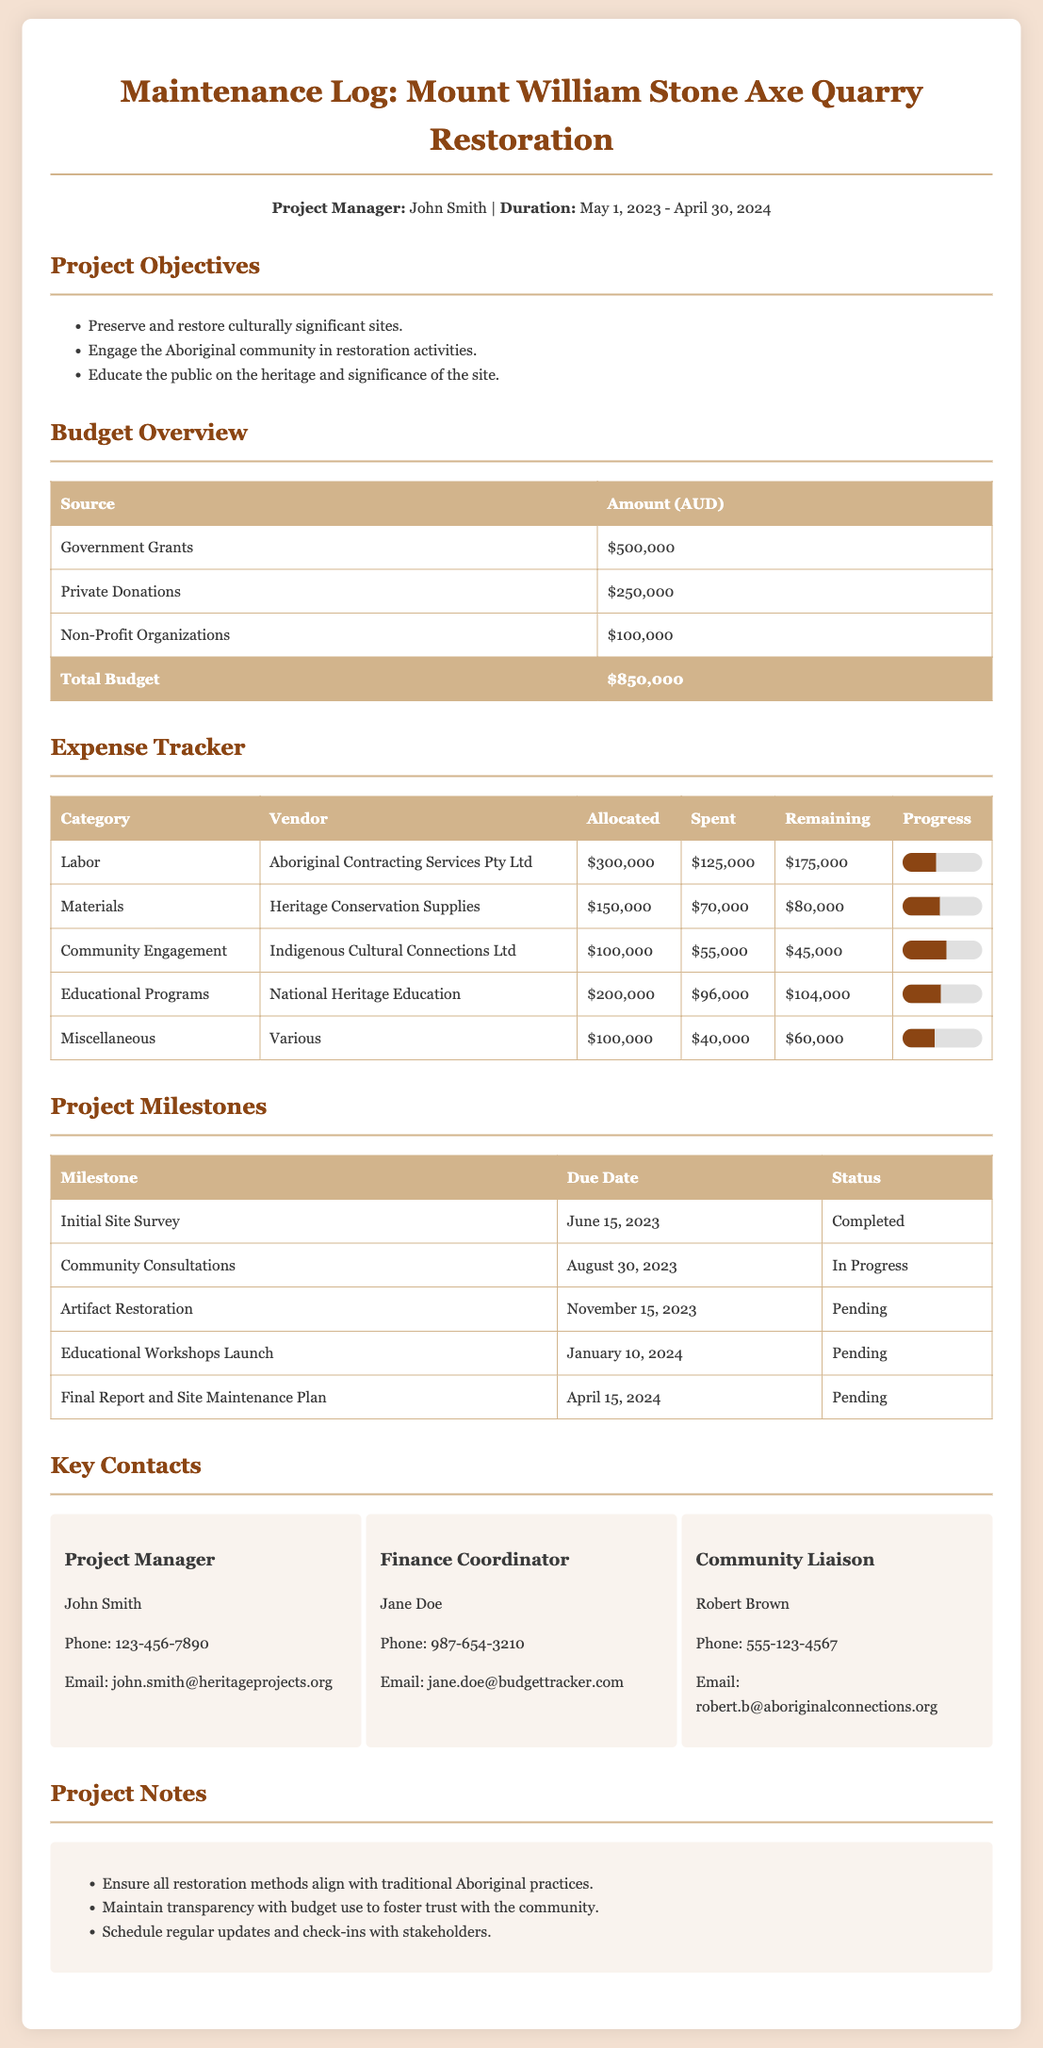What is the total budget for the restoration project? The total budget is listed as the sum of all funding sources in the document, which is $500,000 + $250,000 + $100,000 = $850,000.
Answer: $850,000 Who is the project manager? The project manager's name is mentioned at the top of the document.
Answer: John Smith What is the allocated amount for community engagement? The allocated amount for community engagement can be found in the expense tracker section.
Answer: $100,000 What is the status of the community consultations milestone? The status of the community consultations is provided in the project milestones table.
Answer: In Progress What is the total amount spent on materials? The total amount spent on materials is specified in the expense tracker under the Materials category.
Answer: $70,000 Which vendor is responsible for Labor expenses? The vendor for Labor expenses is mentioned in the expense tracker table for that category.
Answer: Aboriginal Contracting Services Pty Ltd What percentage of the educational programs budget has been spent? The percentage can be calculated from the spent and allocated amounts for educational programs in the expense tracker.
Answer: 48% What is the target due date for the final report and site maintenance plan? The due date for the final report is provided in the milestones table.
Answer: April 15, 2024 How many key contacts are listed in the document? The number of key contacts can be counted from the section listing them.
Answer: 3 